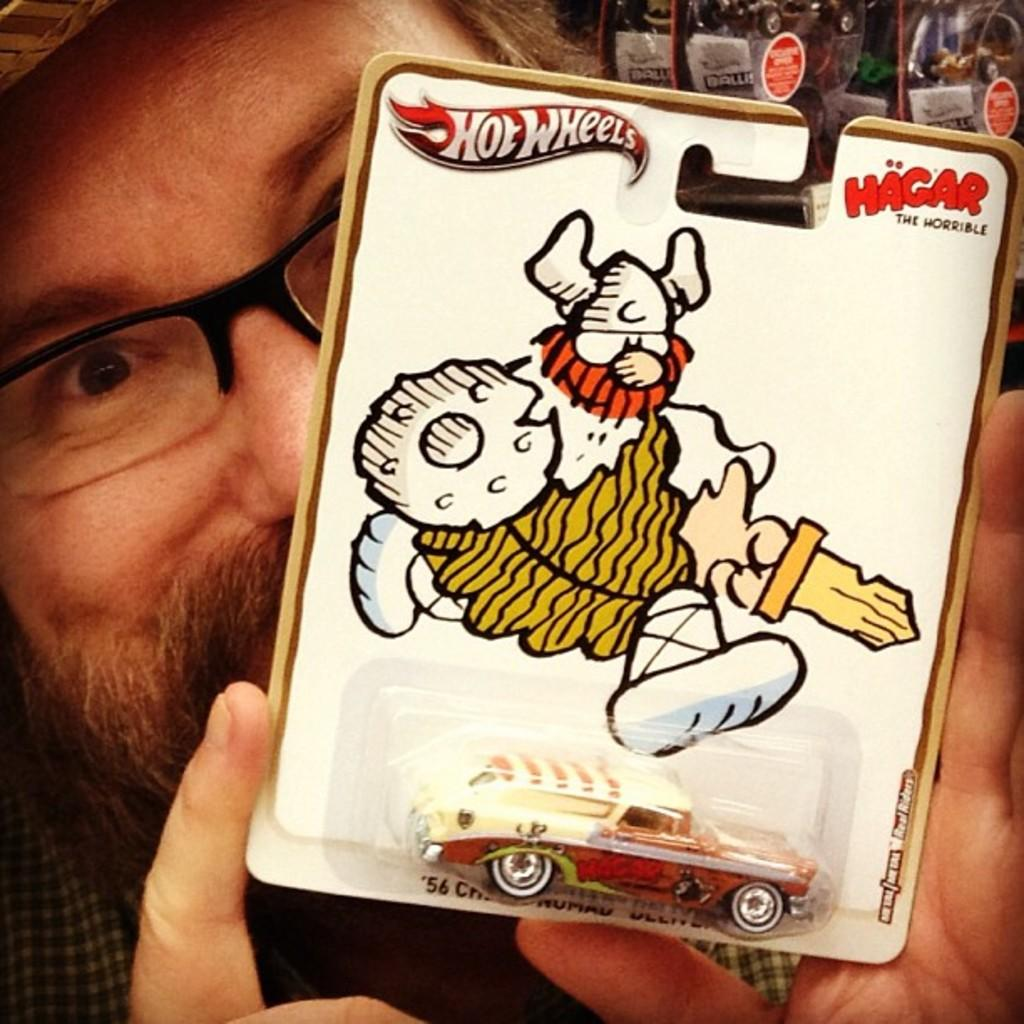What is the main subject of the image? There is a person in the image. What is the person holding in the image? The person is holding something. Can you describe any objects visible in the background of the image? There are a few objects visible in the background of the image. What type of nail is being used in the religious ceremony in the image? There is no nail or religious ceremony present in the image; it features a person holding something with a few objects visible in the background. 